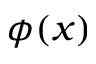Convert formula to latex. <formula><loc_0><loc_0><loc_500><loc_500>\phi ( x )</formula> 